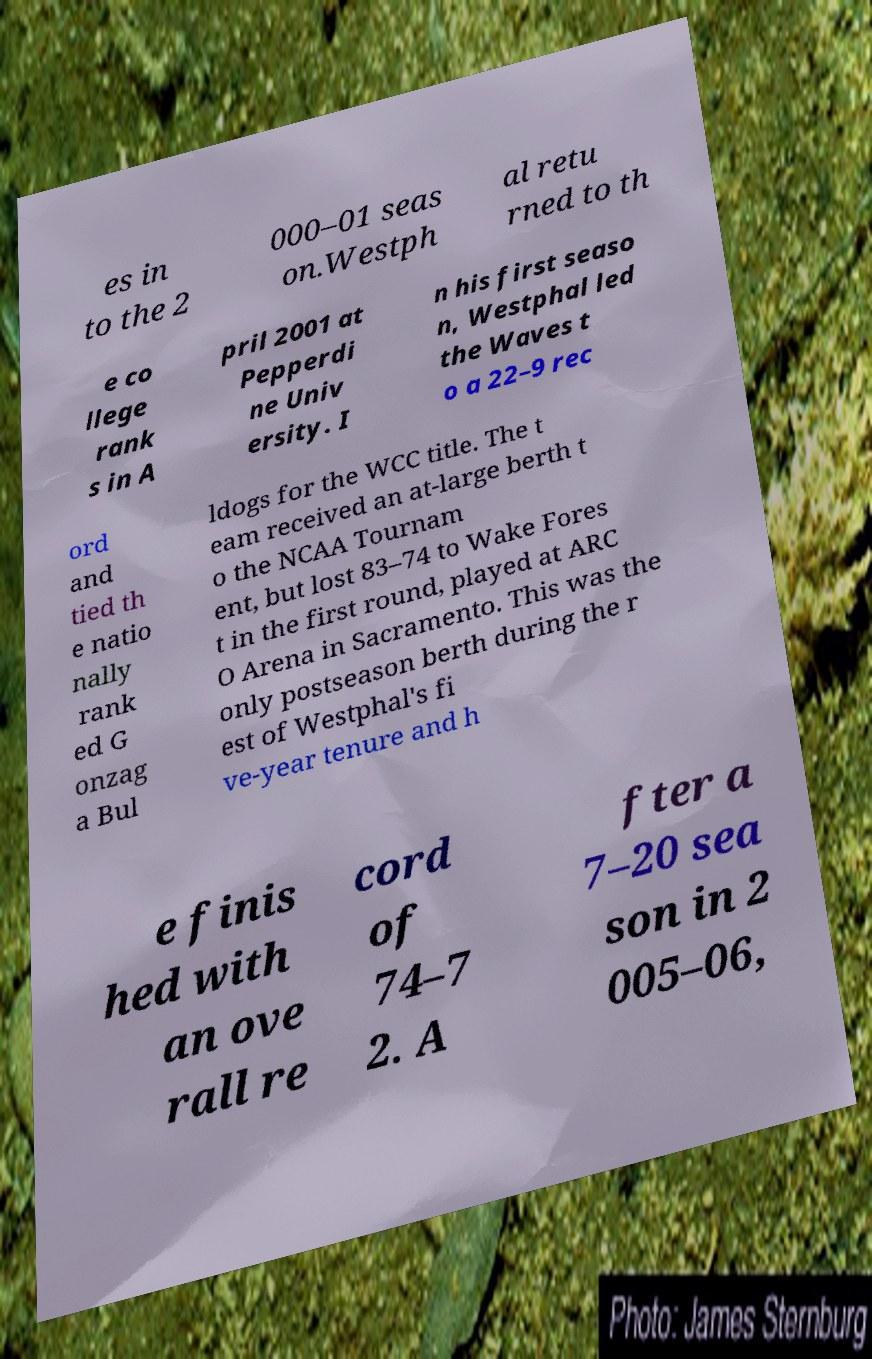Could you assist in decoding the text presented in this image and type it out clearly? es in to the 2 000–01 seas on.Westph al retu rned to th e co llege rank s in A pril 2001 at Pepperdi ne Univ ersity. I n his first seaso n, Westphal led the Waves t o a 22–9 rec ord and tied th e natio nally rank ed G onzag a Bul ldogs for the WCC title. The t eam received an at-large berth t o the NCAA Tournam ent, but lost 83–74 to Wake Fores t in the first round, played at ARC O Arena in Sacramento. This was the only postseason berth during the r est of Westphal's fi ve-year tenure and h e finis hed with an ove rall re cord of 74–7 2. A fter a 7–20 sea son in 2 005–06, 